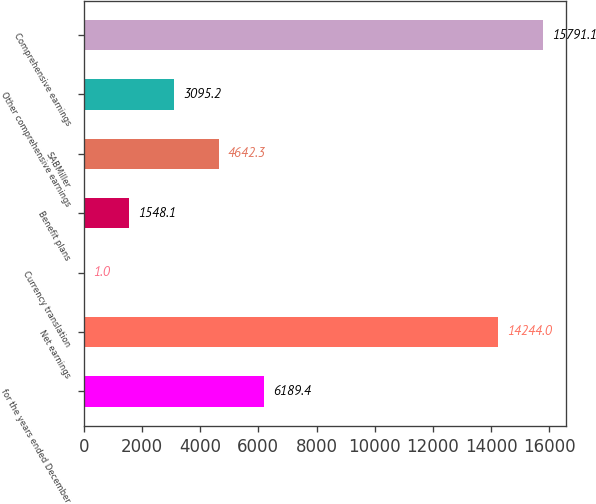Convert chart to OTSL. <chart><loc_0><loc_0><loc_500><loc_500><bar_chart><fcel>for the years ended December<fcel>Net earnings<fcel>Currency translation<fcel>Benefit plans<fcel>SABMiller<fcel>Other comprehensive earnings<fcel>Comprehensive earnings<nl><fcel>6189.4<fcel>14244<fcel>1<fcel>1548.1<fcel>4642.3<fcel>3095.2<fcel>15791.1<nl></chart> 